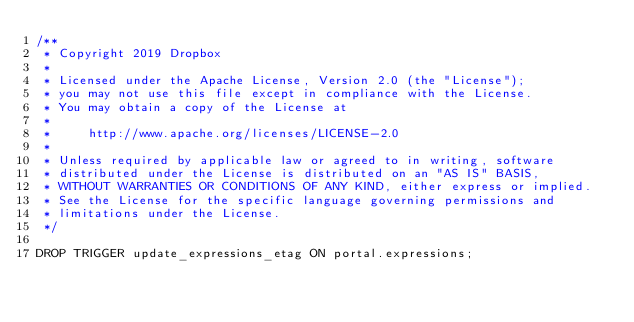<code> <loc_0><loc_0><loc_500><loc_500><_SQL_>/**
 * Copyright 2019 Dropbox
 *
 * Licensed under the Apache License, Version 2.0 (the "License");
 * you may not use this file except in compliance with the License.
 * You may obtain a copy of the License at
 *
 *     http://www.apache.org/licenses/LICENSE-2.0
 *
 * Unless required by applicable law or agreed to in writing, software
 * distributed under the License is distributed on an "AS IS" BASIS,
 * WITHOUT WARRANTIES OR CONDITIONS OF ANY KIND, either express or implied.
 * See the License for the specific language governing permissions and
 * limitations under the License.
 */

DROP TRIGGER update_expressions_etag ON portal.expressions;
</code> 